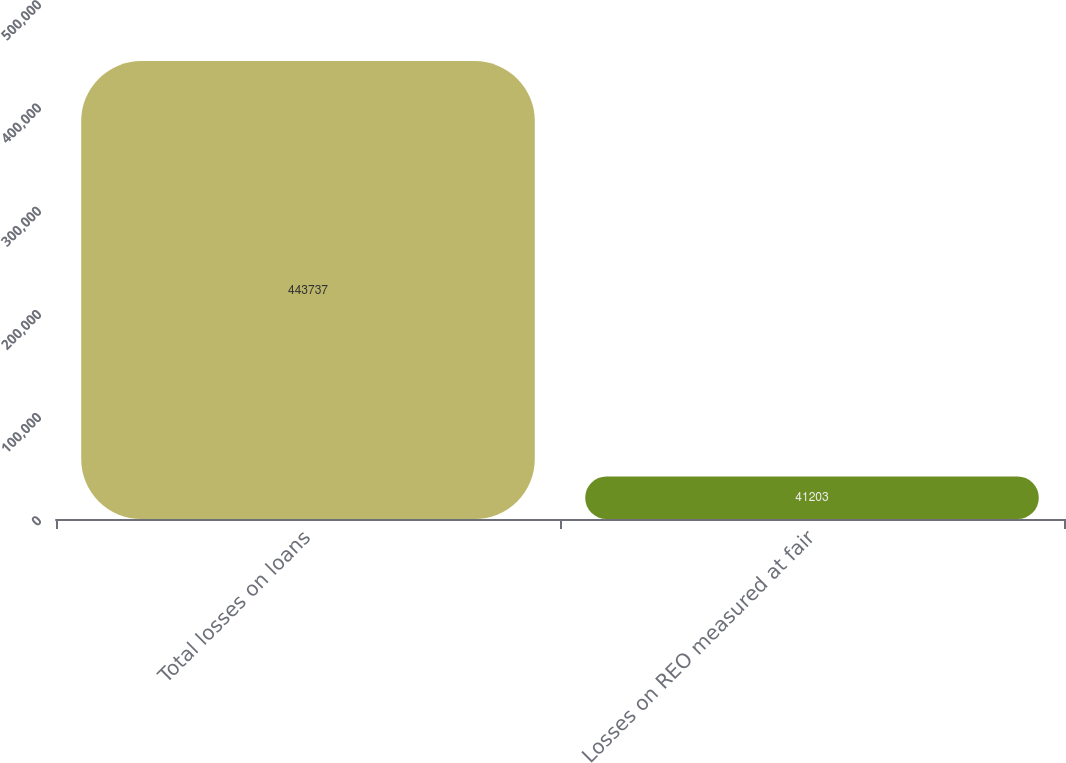Convert chart to OTSL. <chart><loc_0><loc_0><loc_500><loc_500><bar_chart><fcel>Total losses on loans<fcel>Losses on REO measured at fair<nl><fcel>443737<fcel>41203<nl></chart> 